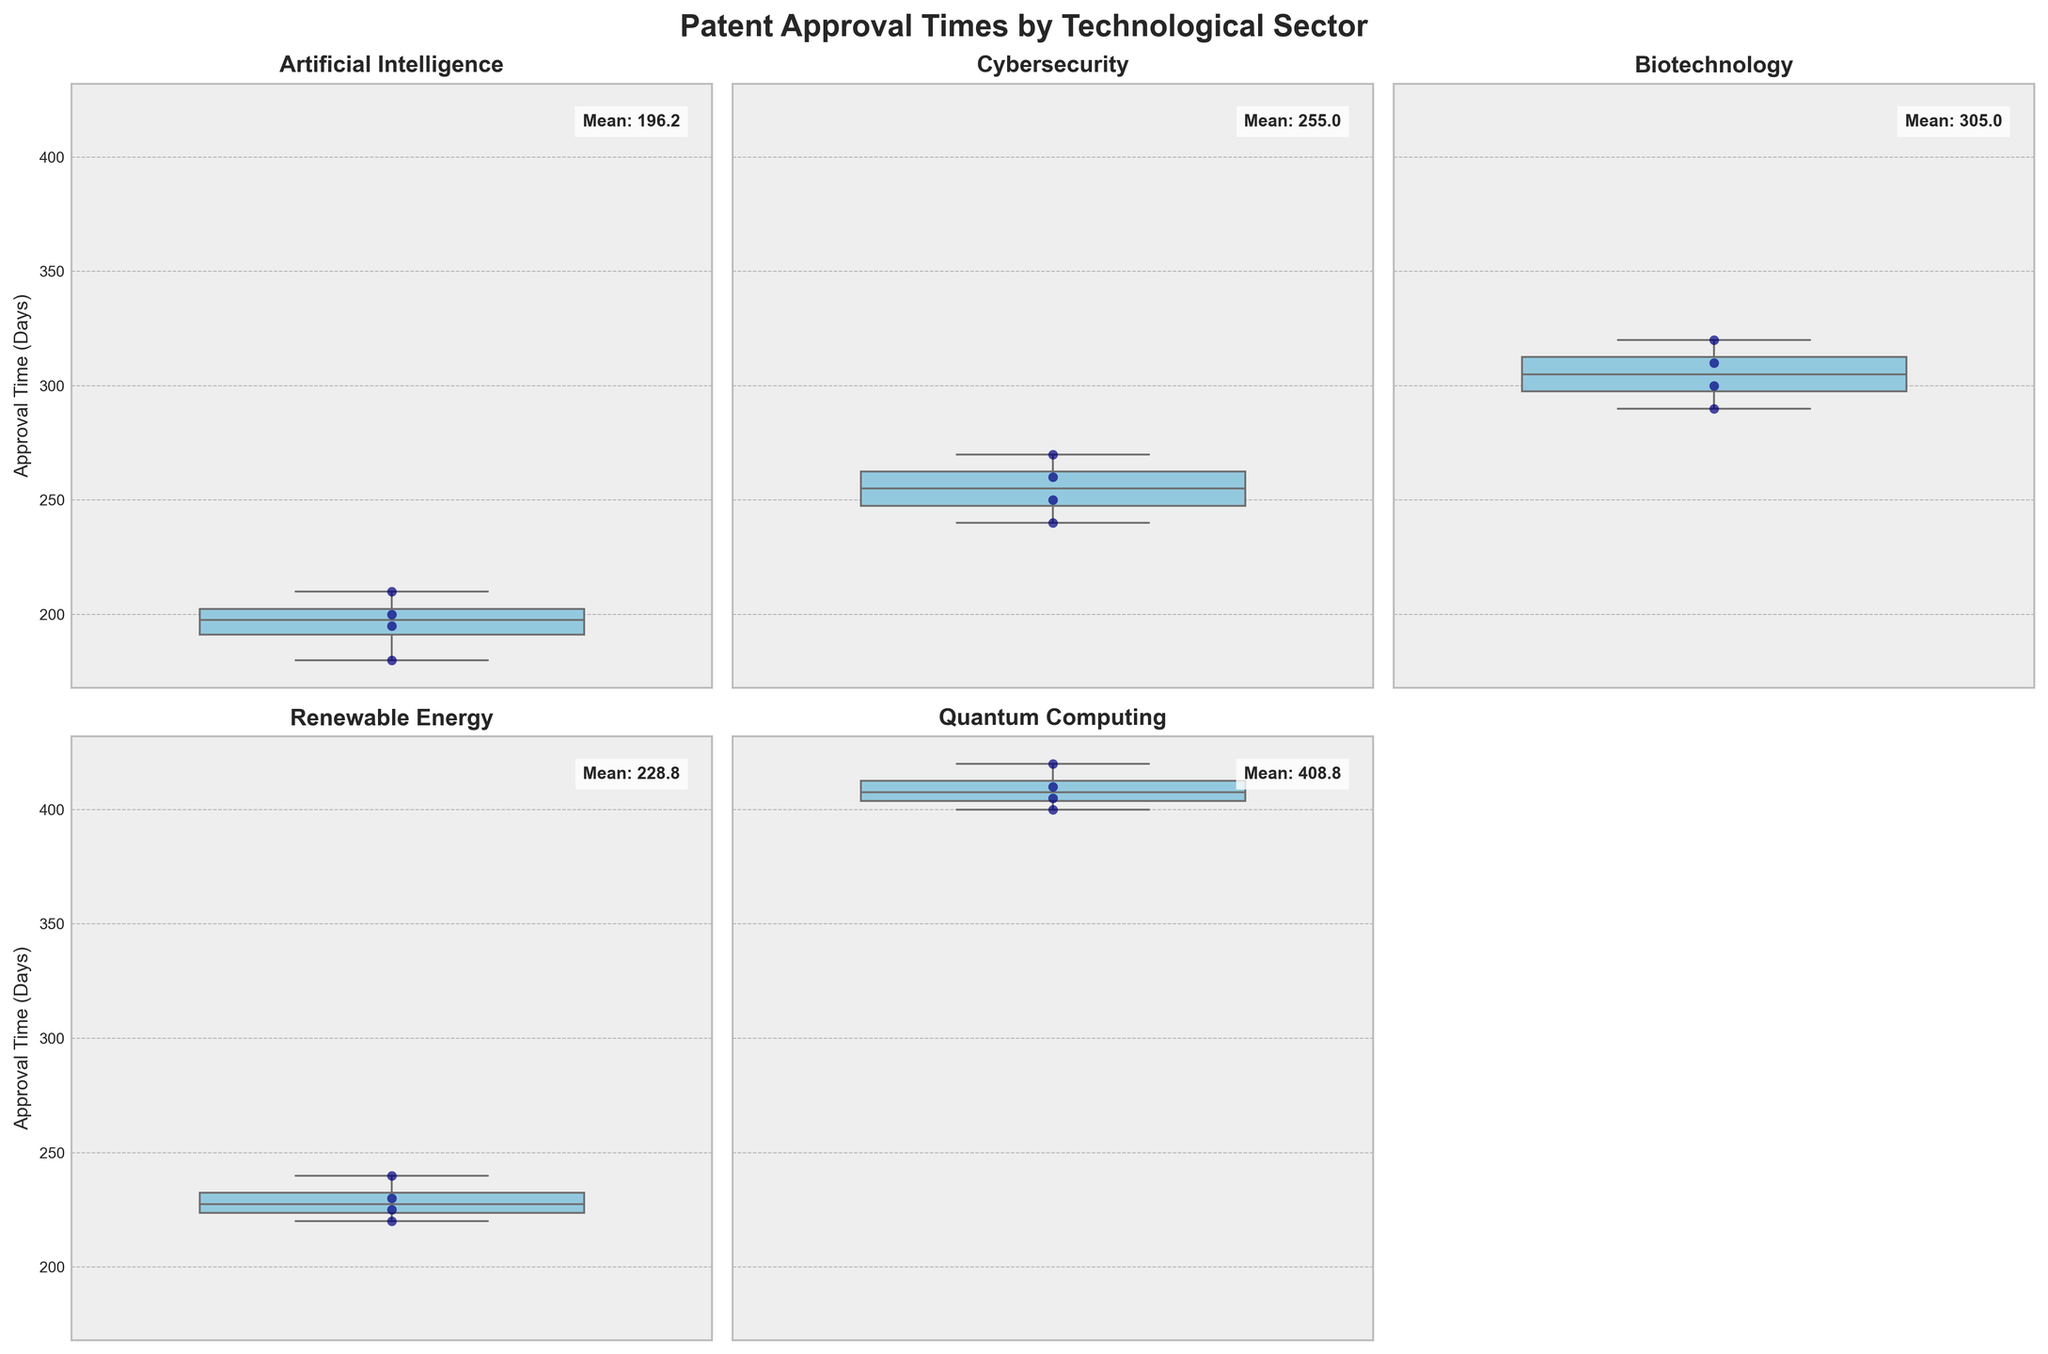How many technological sectors are compared in the box plots? The figure contains six total subplots, but one is removed, so we can list five technological sectors by looking at the titles of each subplot.
Answer: Five Which technological sector has the highest mean patent approval time? By inspecting the mean values added as text in each subplot, the Quantum Computing sector has the highest mean with a value of around 408.8 days.
Answer: Quantum Computing What is the approximate difference between the mean patent approval times of Artificial Intelligence and Cybersecurity? The mean of Artificial Intelligence sector is around 196.3 and for Cybersecurity, it is around 255.0. Subtracting gives us 255.0 - 196.3 = 58.7 days.
Answer: 58.7 days Which sector has the smallest spread in patent approval times, as visible from the box plot range? By observing the range of the box plots, Renewable Energy has the smallest spread, as the interquartile range (IQR) seems narrower compared to other sectors.
Answer: Renewable Energy What is the median patent approval time for the 5G Networks sector? The median value for 5G Networks can be identified as the central line within the box, which appears to be around 210.
Answer: 210 days Between Biotechnology and Quantum Computing sectors, which one has a higher variability in patent approval times? Looking at the box plot ranges and also taking into account the outliers, Quantum Computing shows a higher variability as its IQR is wider and the overall range is greater.
Answer: Quantum Computing Are there any outliers in the Artificial Intelligence sector based on the box plot? An outlier would be a point outside the whiskers of the box plot. There are no points outside the whiskers for Artificial Intelligence, indicating no visible outliers.
Answer: No Which technological sector has the lower bound of its interquartile range at the highest value? By examining the lower bounds of each box plot, Quantum Computing has the highest lower bound, as its box begins at around 400 days.
Answer: Quantum Computing 